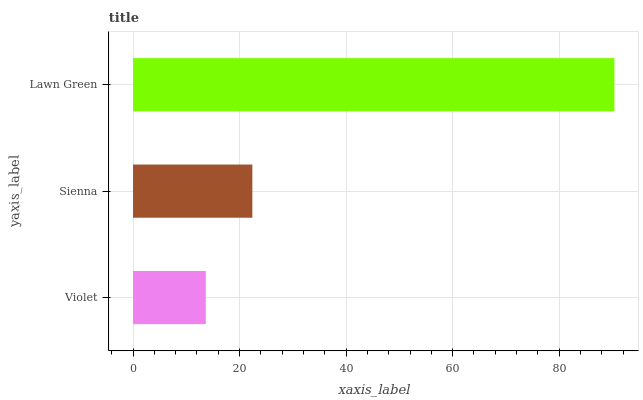Is Violet the minimum?
Answer yes or no. Yes. Is Lawn Green the maximum?
Answer yes or no. Yes. Is Sienna the minimum?
Answer yes or no. No. Is Sienna the maximum?
Answer yes or no. No. Is Sienna greater than Violet?
Answer yes or no. Yes. Is Violet less than Sienna?
Answer yes or no. Yes. Is Violet greater than Sienna?
Answer yes or no. No. Is Sienna less than Violet?
Answer yes or no. No. Is Sienna the high median?
Answer yes or no. Yes. Is Sienna the low median?
Answer yes or no. Yes. Is Violet the high median?
Answer yes or no. No. Is Lawn Green the low median?
Answer yes or no. No. 